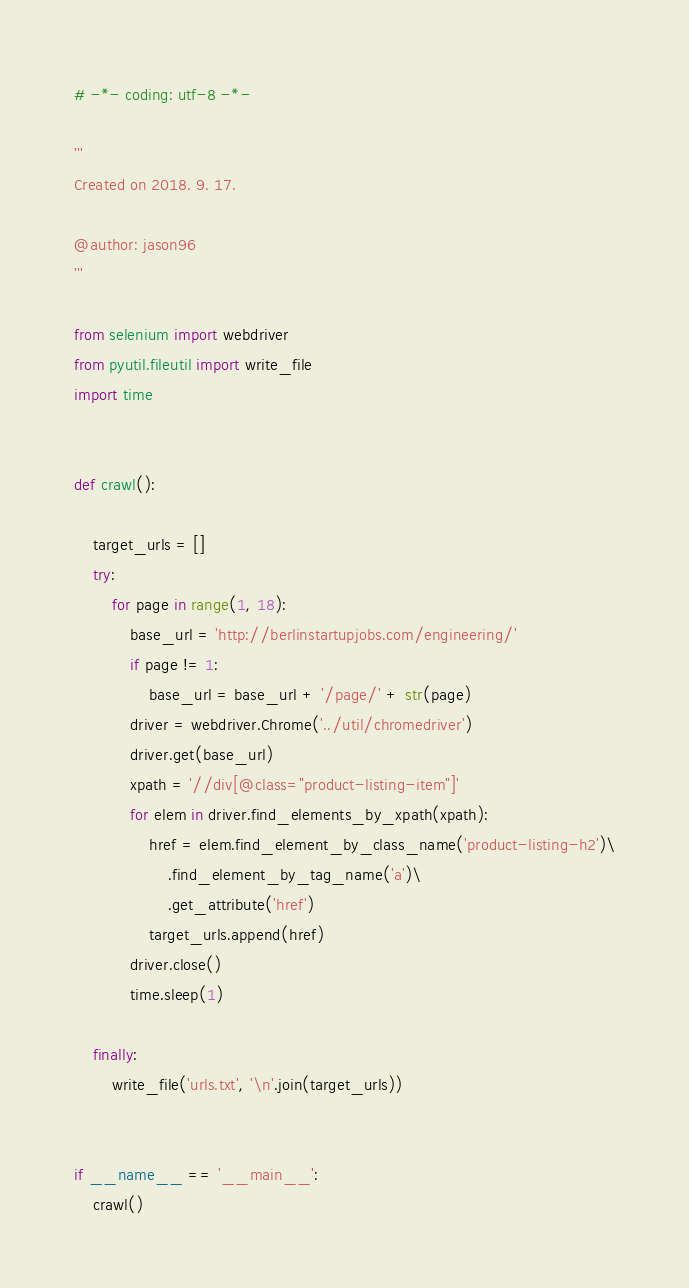<code> <loc_0><loc_0><loc_500><loc_500><_Python_># -*- coding: utf-8 -*-

'''
Created on 2018. 9. 17.

@author: jason96
'''

from selenium import webdriver
from pyutil.fileutil import write_file
import time


def crawl():

    target_urls = []
    try:
        for page in range(1, 18):
            base_url = 'http://berlinstartupjobs.com/engineering/'
            if page != 1:
                base_url = base_url + '/page/' + str(page)
            driver = webdriver.Chrome('../util/chromedriver')
            driver.get(base_url)
            xpath = '//div[@class="product-listing-item"]'
            for elem in driver.find_elements_by_xpath(xpath):
                href = elem.find_element_by_class_name('product-listing-h2')\
                    .find_element_by_tag_name('a')\
                    .get_attribute('href')
                target_urls.append(href)
            driver.close()
            time.sleep(1)

    finally:
        write_file('urls.txt', '\n'.join(target_urls))


if __name__ == '__main__':
    crawl()
</code> 